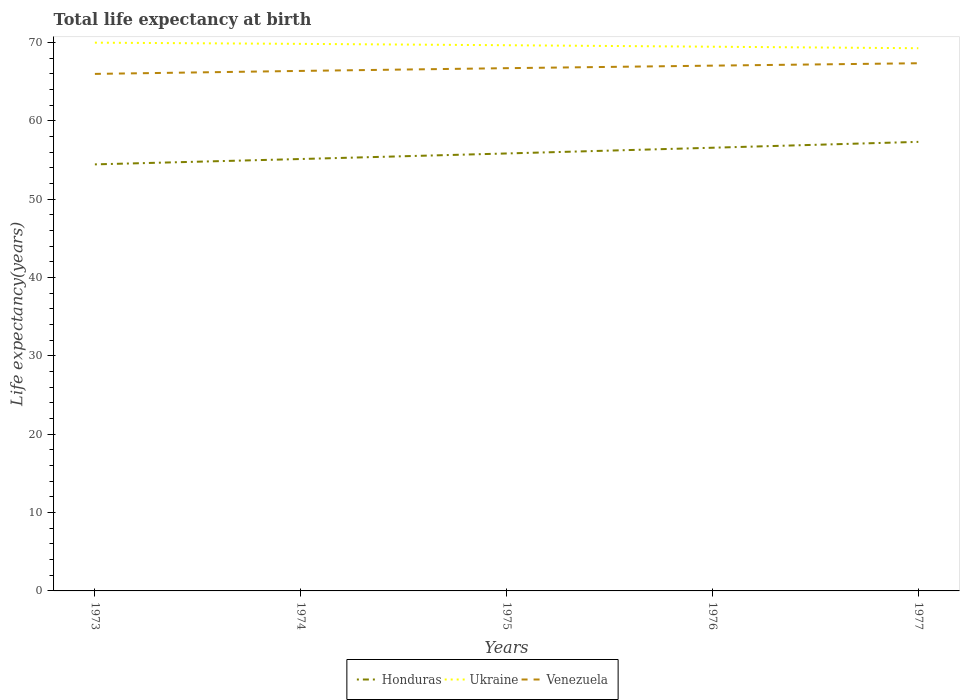How many different coloured lines are there?
Keep it short and to the point. 3. Across all years, what is the maximum life expectancy at birth in in Ukraine?
Offer a terse response. 69.25. In which year was the life expectancy at birth in in Ukraine maximum?
Provide a short and direct response. 1977. What is the total life expectancy at birth in in Venezuela in the graph?
Make the answer very short. -0.98. What is the difference between the highest and the second highest life expectancy at birth in in Venezuela?
Your response must be concise. 1.36. How many years are there in the graph?
Your response must be concise. 5. What is the difference between two consecutive major ticks on the Y-axis?
Keep it short and to the point. 10. Are the values on the major ticks of Y-axis written in scientific E-notation?
Your response must be concise. No. Does the graph contain any zero values?
Make the answer very short. No. How many legend labels are there?
Make the answer very short. 3. How are the legend labels stacked?
Ensure brevity in your answer.  Horizontal. What is the title of the graph?
Your answer should be compact. Total life expectancy at birth. Does "Upper middle income" appear as one of the legend labels in the graph?
Provide a succinct answer. No. What is the label or title of the Y-axis?
Keep it short and to the point. Life expectancy(years). What is the Life expectancy(years) of Honduras in 1973?
Your answer should be compact. 54.43. What is the Life expectancy(years) in Ukraine in 1973?
Ensure brevity in your answer.  69.96. What is the Life expectancy(years) in Venezuela in 1973?
Your answer should be compact. 65.98. What is the Life expectancy(years) of Honduras in 1974?
Give a very brief answer. 55.12. What is the Life expectancy(years) in Ukraine in 1974?
Your response must be concise. 69.81. What is the Life expectancy(years) in Venezuela in 1974?
Keep it short and to the point. 66.36. What is the Life expectancy(years) in Honduras in 1975?
Make the answer very short. 55.82. What is the Life expectancy(years) of Ukraine in 1975?
Offer a very short reply. 69.63. What is the Life expectancy(years) of Venezuela in 1975?
Offer a very short reply. 66.71. What is the Life expectancy(years) of Honduras in 1976?
Keep it short and to the point. 56.55. What is the Life expectancy(years) in Ukraine in 1976?
Offer a very short reply. 69.45. What is the Life expectancy(years) in Venezuela in 1976?
Ensure brevity in your answer.  67.03. What is the Life expectancy(years) of Honduras in 1977?
Keep it short and to the point. 57.3. What is the Life expectancy(years) in Ukraine in 1977?
Your answer should be very brief. 69.25. What is the Life expectancy(years) in Venezuela in 1977?
Offer a terse response. 67.34. Across all years, what is the maximum Life expectancy(years) in Honduras?
Your answer should be compact. 57.3. Across all years, what is the maximum Life expectancy(years) of Ukraine?
Provide a succinct answer. 69.96. Across all years, what is the maximum Life expectancy(years) of Venezuela?
Provide a short and direct response. 67.34. Across all years, what is the minimum Life expectancy(years) of Honduras?
Offer a terse response. 54.43. Across all years, what is the minimum Life expectancy(years) in Ukraine?
Your response must be concise. 69.25. Across all years, what is the minimum Life expectancy(years) in Venezuela?
Your response must be concise. 65.98. What is the total Life expectancy(years) in Honduras in the graph?
Ensure brevity in your answer.  279.23. What is the total Life expectancy(years) in Ukraine in the graph?
Your answer should be compact. 348.11. What is the total Life expectancy(years) of Venezuela in the graph?
Give a very brief answer. 333.41. What is the difference between the Life expectancy(years) of Honduras in 1973 and that in 1974?
Provide a short and direct response. -0.68. What is the difference between the Life expectancy(years) in Ukraine in 1973 and that in 1974?
Offer a very short reply. 0.15. What is the difference between the Life expectancy(years) of Venezuela in 1973 and that in 1974?
Make the answer very short. -0.38. What is the difference between the Life expectancy(years) of Honduras in 1973 and that in 1975?
Keep it short and to the point. -1.39. What is the difference between the Life expectancy(years) of Ukraine in 1973 and that in 1975?
Your response must be concise. 0.33. What is the difference between the Life expectancy(years) of Venezuela in 1973 and that in 1975?
Provide a succinct answer. -0.73. What is the difference between the Life expectancy(years) of Honduras in 1973 and that in 1976?
Make the answer very short. -2.12. What is the difference between the Life expectancy(years) of Ukraine in 1973 and that in 1976?
Provide a succinct answer. 0.52. What is the difference between the Life expectancy(years) of Venezuela in 1973 and that in 1976?
Your answer should be compact. -1.05. What is the difference between the Life expectancy(years) in Honduras in 1973 and that in 1977?
Provide a succinct answer. -2.87. What is the difference between the Life expectancy(years) of Ukraine in 1973 and that in 1977?
Make the answer very short. 0.71. What is the difference between the Life expectancy(years) of Venezuela in 1973 and that in 1977?
Provide a succinct answer. -1.36. What is the difference between the Life expectancy(years) of Honduras in 1974 and that in 1975?
Ensure brevity in your answer.  -0.71. What is the difference between the Life expectancy(years) in Ukraine in 1974 and that in 1975?
Your response must be concise. 0.17. What is the difference between the Life expectancy(years) in Venezuela in 1974 and that in 1975?
Your answer should be very brief. -0.35. What is the difference between the Life expectancy(years) of Honduras in 1974 and that in 1976?
Make the answer very short. -1.44. What is the difference between the Life expectancy(years) of Ukraine in 1974 and that in 1976?
Make the answer very short. 0.36. What is the difference between the Life expectancy(years) of Venezuela in 1974 and that in 1976?
Ensure brevity in your answer.  -0.67. What is the difference between the Life expectancy(years) of Honduras in 1974 and that in 1977?
Your answer should be compact. -2.19. What is the difference between the Life expectancy(years) of Ukraine in 1974 and that in 1977?
Ensure brevity in your answer.  0.56. What is the difference between the Life expectancy(years) in Venezuela in 1974 and that in 1977?
Offer a terse response. -0.98. What is the difference between the Life expectancy(years) in Honduras in 1975 and that in 1976?
Provide a short and direct response. -0.73. What is the difference between the Life expectancy(years) in Ukraine in 1975 and that in 1976?
Provide a succinct answer. 0.19. What is the difference between the Life expectancy(years) of Venezuela in 1975 and that in 1976?
Your answer should be compact. -0.32. What is the difference between the Life expectancy(years) in Honduras in 1975 and that in 1977?
Provide a short and direct response. -1.48. What is the difference between the Life expectancy(years) of Ukraine in 1975 and that in 1977?
Keep it short and to the point. 0.38. What is the difference between the Life expectancy(years) in Venezuela in 1975 and that in 1977?
Provide a succinct answer. -0.63. What is the difference between the Life expectancy(years) in Honduras in 1976 and that in 1977?
Provide a succinct answer. -0.75. What is the difference between the Life expectancy(years) of Ukraine in 1976 and that in 1977?
Your answer should be very brief. 0.19. What is the difference between the Life expectancy(years) of Venezuela in 1976 and that in 1977?
Offer a very short reply. -0.31. What is the difference between the Life expectancy(years) of Honduras in 1973 and the Life expectancy(years) of Ukraine in 1974?
Give a very brief answer. -15.38. What is the difference between the Life expectancy(years) of Honduras in 1973 and the Life expectancy(years) of Venezuela in 1974?
Make the answer very short. -11.93. What is the difference between the Life expectancy(years) in Ukraine in 1973 and the Life expectancy(years) in Venezuela in 1974?
Offer a very short reply. 3.61. What is the difference between the Life expectancy(years) of Honduras in 1973 and the Life expectancy(years) of Ukraine in 1975?
Your response must be concise. -15.2. What is the difference between the Life expectancy(years) in Honduras in 1973 and the Life expectancy(years) in Venezuela in 1975?
Keep it short and to the point. -12.28. What is the difference between the Life expectancy(years) of Ukraine in 1973 and the Life expectancy(years) of Venezuela in 1975?
Your answer should be very brief. 3.26. What is the difference between the Life expectancy(years) in Honduras in 1973 and the Life expectancy(years) in Ukraine in 1976?
Your answer should be compact. -15.02. What is the difference between the Life expectancy(years) in Honduras in 1973 and the Life expectancy(years) in Venezuela in 1976?
Your answer should be compact. -12.6. What is the difference between the Life expectancy(years) of Ukraine in 1973 and the Life expectancy(years) of Venezuela in 1976?
Your response must be concise. 2.93. What is the difference between the Life expectancy(years) in Honduras in 1973 and the Life expectancy(years) in Ukraine in 1977?
Offer a terse response. -14.82. What is the difference between the Life expectancy(years) of Honduras in 1973 and the Life expectancy(years) of Venezuela in 1977?
Keep it short and to the point. -12.91. What is the difference between the Life expectancy(years) in Ukraine in 1973 and the Life expectancy(years) in Venezuela in 1977?
Offer a terse response. 2.63. What is the difference between the Life expectancy(years) in Honduras in 1974 and the Life expectancy(years) in Ukraine in 1975?
Provide a short and direct response. -14.52. What is the difference between the Life expectancy(years) in Honduras in 1974 and the Life expectancy(years) in Venezuela in 1975?
Give a very brief answer. -11.59. What is the difference between the Life expectancy(years) of Ukraine in 1974 and the Life expectancy(years) of Venezuela in 1975?
Ensure brevity in your answer.  3.1. What is the difference between the Life expectancy(years) of Honduras in 1974 and the Life expectancy(years) of Ukraine in 1976?
Your answer should be very brief. -14.33. What is the difference between the Life expectancy(years) in Honduras in 1974 and the Life expectancy(years) in Venezuela in 1976?
Provide a succinct answer. -11.92. What is the difference between the Life expectancy(years) of Ukraine in 1974 and the Life expectancy(years) of Venezuela in 1976?
Keep it short and to the point. 2.78. What is the difference between the Life expectancy(years) of Honduras in 1974 and the Life expectancy(years) of Ukraine in 1977?
Make the answer very short. -14.14. What is the difference between the Life expectancy(years) of Honduras in 1974 and the Life expectancy(years) of Venezuela in 1977?
Offer a very short reply. -12.22. What is the difference between the Life expectancy(years) in Ukraine in 1974 and the Life expectancy(years) in Venezuela in 1977?
Ensure brevity in your answer.  2.47. What is the difference between the Life expectancy(years) of Honduras in 1975 and the Life expectancy(years) of Ukraine in 1976?
Your response must be concise. -13.62. What is the difference between the Life expectancy(years) in Honduras in 1975 and the Life expectancy(years) in Venezuela in 1976?
Offer a terse response. -11.21. What is the difference between the Life expectancy(years) of Ukraine in 1975 and the Life expectancy(years) of Venezuela in 1976?
Provide a short and direct response. 2.6. What is the difference between the Life expectancy(years) in Honduras in 1975 and the Life expectancy(years) in Ukraine in 1977?
Provide a succinct answer. -13.43. What is the difference between the Life expectancy(years) in Honduras in 1975 and the Life expectancy(years) in Venezuela in 1977?
Your answer should be very brief. -11.51. What is the difference between the Life expectancy(years) in Ukraine in 1975 and the Life expectancy(years) in Venezuela in 1977?
Your response must be concise. 2.3. What is the difference between the Life expectancy(years) in Honduras in 1976 and the Life expectancy(years) in Ukraine in 1977?
Keep it short and to the point. -12.7. What is the difference between the Life expectancy(years) of Honduras in 1976 and the Life expectancy(years) of Venezuela in 1977?
Provide a succinct answer. -10.78. What is the difference between the Life expectancy(years) of Ukraine in 1976 and the Life expectancy(years) of Venezuela in 1977?
Your answer should be very brief. 2.11. What is the average Life expectancy(years) in Honduras per year?
Your answer should be compact. 55.85. What is the average Life expectancy(years) in Ukraine per year?
Your response must be concise. 69.62. What is the average Life expectancy(years) in Venezuela per year?
Make the answer very short. 66.68. In the year 1973, what is the difference between the Life expectancy(years) of Honduras and Life expectancy(years) of Ukraine?
Your answer should be compact. -15.53. In the year 1973, what is the difference between the Life expectancy(years) in Honduras and Life expectancy(years) in Venezuela?
Keep it short and to the point. -11.55. In the year 1973, what is the difference between the Life expectancy(years) in Ukraine and Life expectancy(years) in Venezuela?
Offer a very short reply. 3.99. In the year 1974, what is the difference between the Life expectancy(years) in Honduras and Life expectancy(years) in Ukraine?
Offer a very short reply. -14.69. In the year 1974, what is the difference between the Life expectancy(years) in Honduras and Life expectancy(years) in Venezuela?
Ensure brevity in your answer.  -11.24. In the year 1974, what is the difference between the Life expectancy(years) in Ukraine and Life expectancy(years) in Venezuela?
Your answer should be compact. 3.45. In the year 1975, what is the difference between the Life expectancy(years) of Honduras and Life expectancy(years) of Ukraine?
Offer a terse response. -13.81. In the year 1975, what is the difference between the Life expectancy(years) in Honduras and Life expectancy(years) in Venezuela?
Keep it short and to the point. -10.88. In the year 1975, what is the difference between the Life expectancy(years) of Ukraine and Life expectancy(years) of Venezuela?
Offer a terse response. 2.93. In the year 1976, what is the difference between the Life expectancy(years) of Honduras and Life expectancy(years) of Ukraine?
Keep it short and to the point. -12.89. In the year 1976, what is the difference between the Life expectancy(years) in Honduras and Life expectancy(years) in Venezuela?
Provide a succinct answer. -10.48. In the year 1976, what is the difference between the Life expectancy(years) in Ukraine and Life expectancy(years) in Venezuela?
Your answer should be compact. 2.42. In the year 1977, what is the difference between the Life expectancy(years) in Honduras and Life expectancy(years) in Ukraine?
Your response must be concise. -11.95. In the year 1977, what is the difference between the Life expectancy(years) of Honduras and Life expectancy(years) of Venezuela?
Your response must be concise. -10.03. In the year 1977, what is the difference between the Life expectancy(years) in Ukraine and Life expectancy(years) in Venezuela?
Keep it short and to the point. 1.92. What is the ratio of the Life expectancy(years) in Honduras in 1973 to that in 1974?
Give a very brief answer. 0.99. What is the ratio of the Life expectancy(years) of Venezuela in 1973 to that in 1974?
Provide a short and direct response. 0.99. What is the ratio of the Life expectancy(years) in Honduras in 1973 to that in 1975?
Offer a very short reply. 0.98. What is the ratio of the Life expectancy(years) of Venezuela in 1973 to that in 1975?
Ensure brevity in your answer.  0.99. What is the ratio of the Life expectancy(years) in Honduras in 1973 to that in 1976?
Provide a succinct answer. 0.96. What is the ratio of the Life expectancy(years) of Ukraine in 1973 to that in 1976?
Your answer should be very brief. 1.01. What is the ratio of the Life expectancy(years) of Venezuela in 1973 to that in 1976?
Offer a very short reply. 0.98. What is the ratio of the Life expectancy(years) in Honduras in 1973 to that in 1977?
Keep it short and to the point. 0.95. What is the ratio of the Life expectancy(years) in Ukraine in 1973 to that in 1977?
Provide a succinct answer. 1.01. What is the ratio of the Life expectancy(years) of Venezuela in 1973 to that in 1977?
Your answer should be compact. 0.98. What is the ratio of the Life expectancy(years) of Honduras in 1974 to that in 1975?
Provide a succinct answer. 0.99. What is the ratio of the Life expectancy(years) of Ukraine in 1974 to that in 1975?
Keep it short and to the point. 1. What is the ratio of the Life expectancy(years) in Venezuela in 1974 to that in 1975?
Offer a very short reply. 0.99. What is the ratio of the Life expectancy(years) of Honduras in 1974 to that in 1976?
Your answer should be compact. 0.97. What is the ratio of the Life expectancy(years) of Honduras in 1974 to that in 1977?
Make the answer very short. 0.96. What is the ratio of the Life expectancy(years) in Venezuela in 1974 to that in 1977?
Provide a short and direct response. 0.99. What is the ratio of the Life expectancy(years) in Honduras in 1975 to that in 1976?
Make the answer very short. 0.99. What is the ratio of the Life expectancy(years) in Venezuela in 1975 to that in 1976?
Keep it short and to the point. 1. What is the ratio of the Life expectancy(years) of Honduras in 1975 to that in 1977?
Your answer should be compact. 0.97. What is the ratio of the Life expectancy(years) in Venezuela in 1975 to that in 1977?
Ensure brevity in your answer.  0.99. What is the ratio of the Life expectancy(years) of Honduras in 1976 to that in 1977?
Keep it short and to the point. 0.99. What is the difference between the highest and the second highest Life expectancy(years) of Honduras?
Make the answer very short. 0.75. What is the difference between the highest and the second highest Life expectancy(years) of Ukraine?
Your response must be concise. 0.15. What is the difference between the highest and the second highest Life expectancy(years) in Venezuela?
Offer a very short reply. 0.31. What is the difference between the highest and the lowest Life expectancy(years) in Honduras?
Provide a succinct answer. 2.87. What is the difference between the highest and the lowest Life expectancy(years) of Ukraine?
Offer a very short reply. 0.71. What is the difference between the highest and the lowest Life expectancy(years) of Venezuela?
Provide a short and direct response. 1.36. 